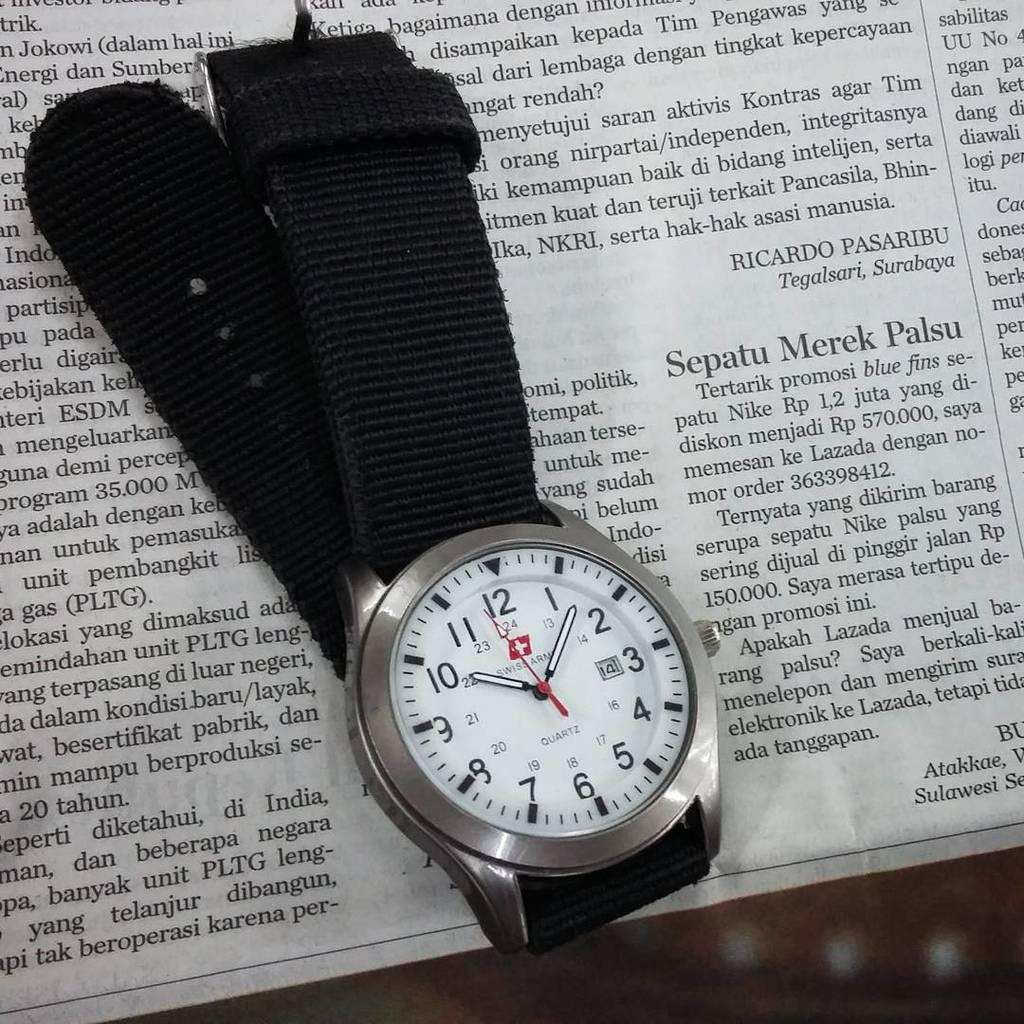Provide a one-sentence caption for the provided image. A Swiss Army is placed on top of a newspaper. 